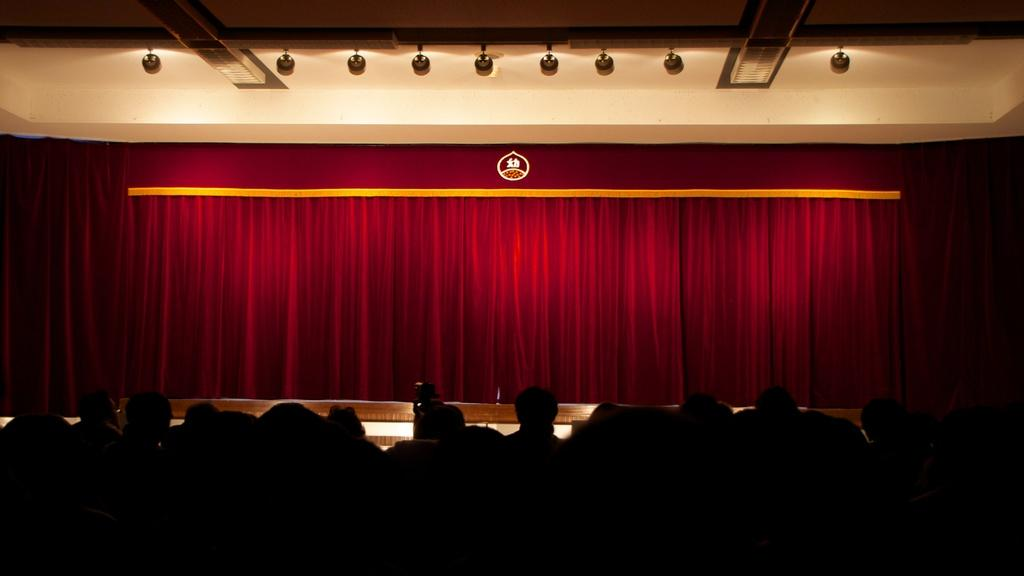What is the main subject of the image? The main subject of the image is a group of people. Can you describe the background of the image? In the background of the image, there are curtains. What type of meat is being distributed by the band in the image? There is no band or meat present in the image; it features a group of people and curtains in the background. 